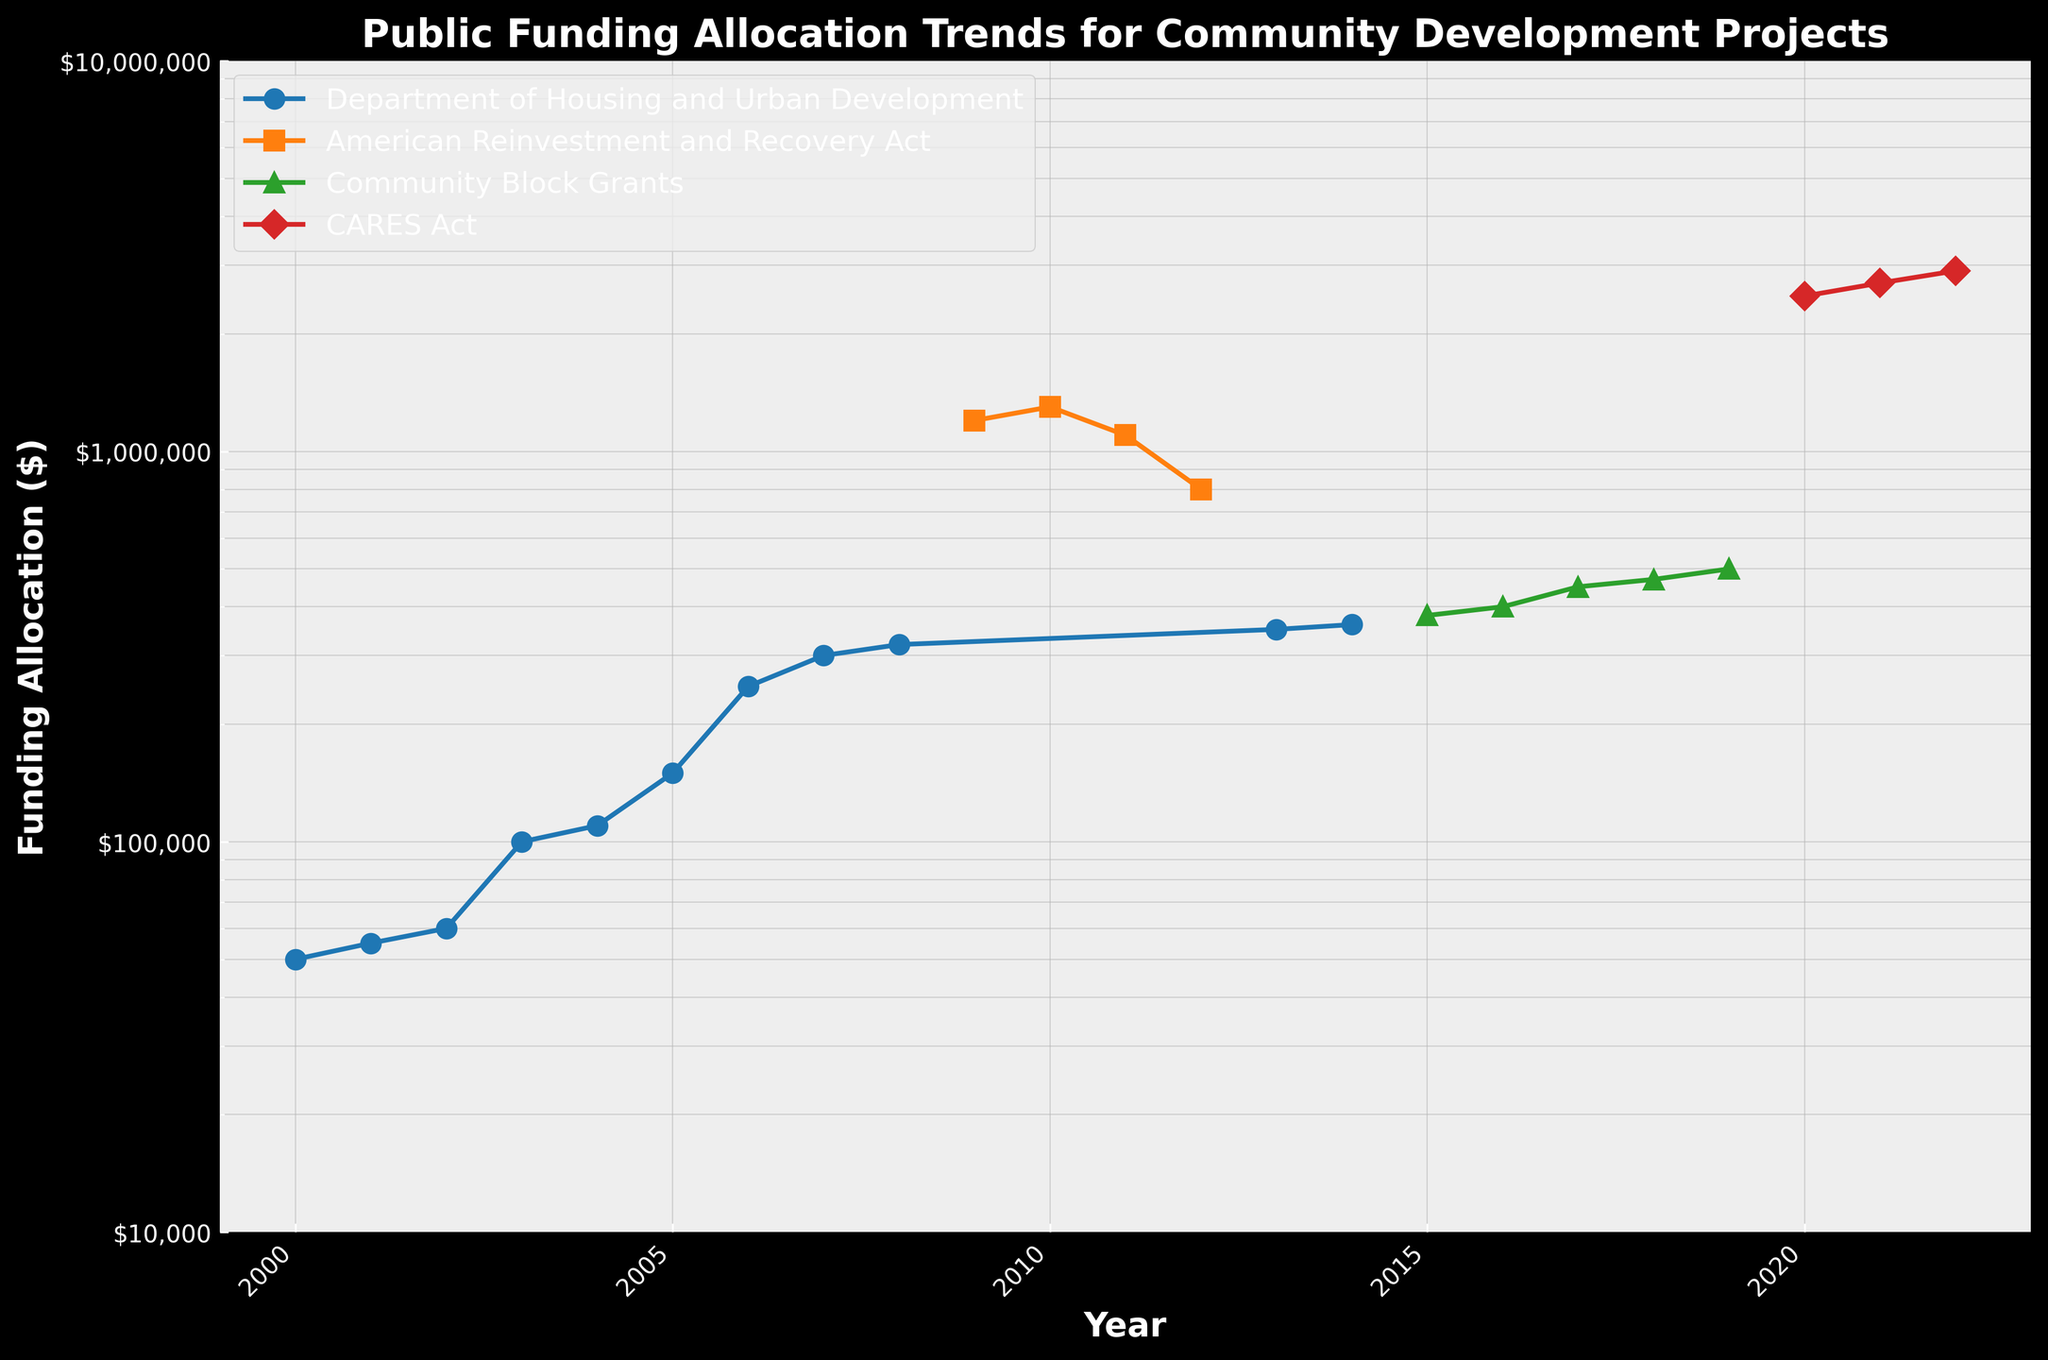What is the title of the figure? The title of the figure is located at the top of the plot, which provides an overall description of what the plot is representing.
Answer: Public Funding Allocation Trends for Community Development Projects How many entities are represented in the figure? Count the number of unique labels in the plot's legend to determine the number of distinct entities represented.
Answer: 4 In what year did the Department of Housing and Urban Development receive the highest funding allocation? Observe the data points corresponding to the Department of Housing and Urban Development and identify the year with the highest y-value on the log scale.
Answer: 2007 How does the funding allocation in 2020 from the CARES Act compare to the funding allocation in 2009 from the American Reinvestment and Recovery Act? Compare the y-values of the CARES Act in 2020 and the American Reinvestment and Recovery Act in 2009 on the log scale axis to understand the difference in magnitude.
Answer: It is higher Which year shows a significant spike in funding allocation for the American Reinvestment and Recovery Act? Identify the year with the highest y-value among the data points corresponding to the American Reinvestment and Recovery Act.
Answer: 2010 What is the approximate funding allocation for the Community Block Grants in 2017? Locate the data point for the Community Block Grants in 2017 and read the corresponding y-value on the log scale.
Answer: $450,000 Between 2008 and 2009, by how much did the funding allocation change when transitioning from the Department of Housing and Urban Development to the American Reinvestment and Recovery Act? Identify the y-values for the Department of Housing and Urban Development in 2008 and the American Reinvestment and Recovery Act in 2009, then calculate the difference.
Answer: $880,000 Which entity had the highest increase in funding allocation between two consecutive years? For each entity, find the year-to-year differences and identify the pair of consecutive years with the largest increase.
Answer: American Reinvestment and Recovery Act (2008 to 2009) In which year did the funding allocation drop significantly for the American Reinvestment and Recovery Act, and what was the amount? Look for the largest decrease in the funding allocation for the American Reinvestment and Recovery Act by comparing consecutive years, and note the year and the two y-values to find the drop amount.
Answer: 2012, $300,000 